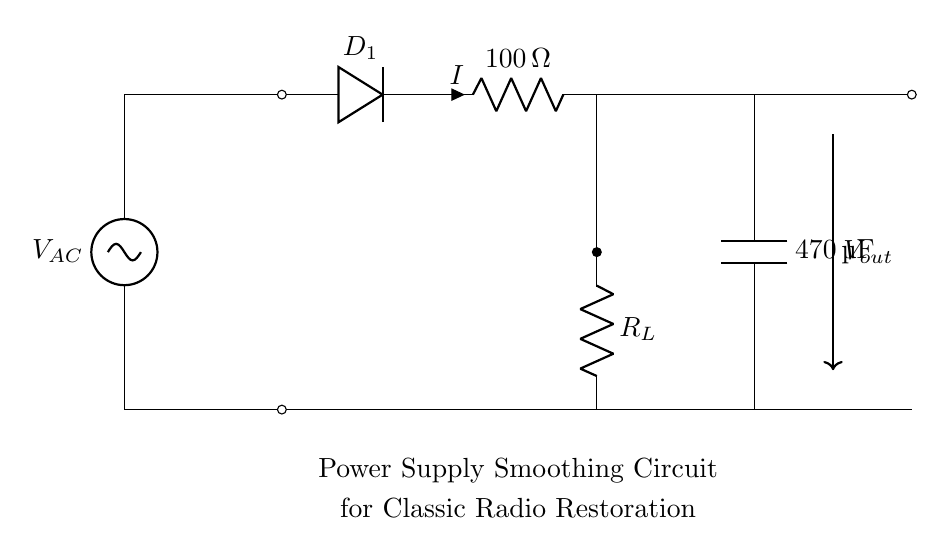What is the input voltage type? The input voltage is represented as V_AC, indicating it is an alternating current (AC) voltage source.
Answer: AC What is the resistance value of the resistor? The resistor is marked with a value of 100 ohms. This is indicated next to the R symbol in the circuit diagram.
Answer: 100 ohms What is the capacitance value of the capacitor? The capacitor's value is specified as 470 microfarads (µF), which is shown next to the C symbol in the diagram.
Answer: 470 microfarads What is the purpose of the capacitor in this circuit? The capacitor's role in a smoothing circuit is to filter out fluctuations in the output voltage, providing a more constant DC voltage. This is due to its property of charging and discharging.
Answer: Smoothing voltage How does the current direction flow from the input to the output? The current, denoted by I, flows from the AC voltage source through the diode and then into the resistor and capacitor in the specified sequence before it reaches the output node. Following the paths indicated by the connections in the schematic will show this direction.
Answer: From left to right What would happen if the capacitor is removed? If the capacitor is removed, the output voltage would become less stable, exhibiting more ripple as the AC waveform would directly affect the output, leading to an unreliable supply for radio restoration.
Answer: Increased ripple Which component rectifies the current in this circuit? The current is rectified by the diode labeled D_1, which allows current to flow in one direction, converting AC to a pulsating DC voltage. This is a critical component in power supply smoothing circuits.
Answer: Diode 